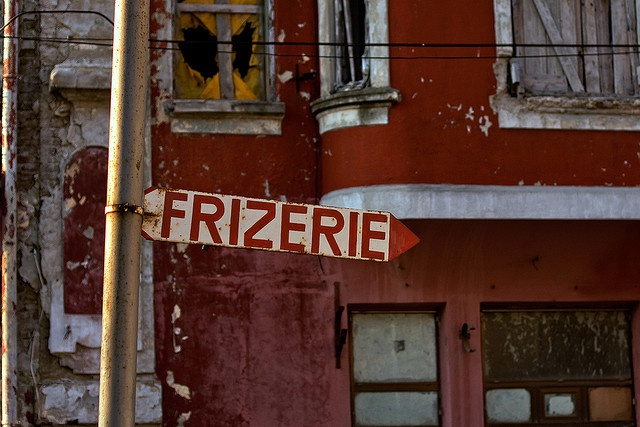Describe the objects in this image and their specific colors. I can see various objects in this image with different colors. 